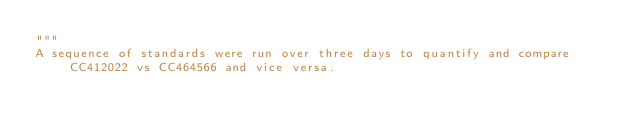<code> <loc_0><loc_0><loc_500><loc_500><_Python_>"""
A sequence of standards were run over three days to quantify and compare CC412022 vs CC464566 and vice versa.
</code> 